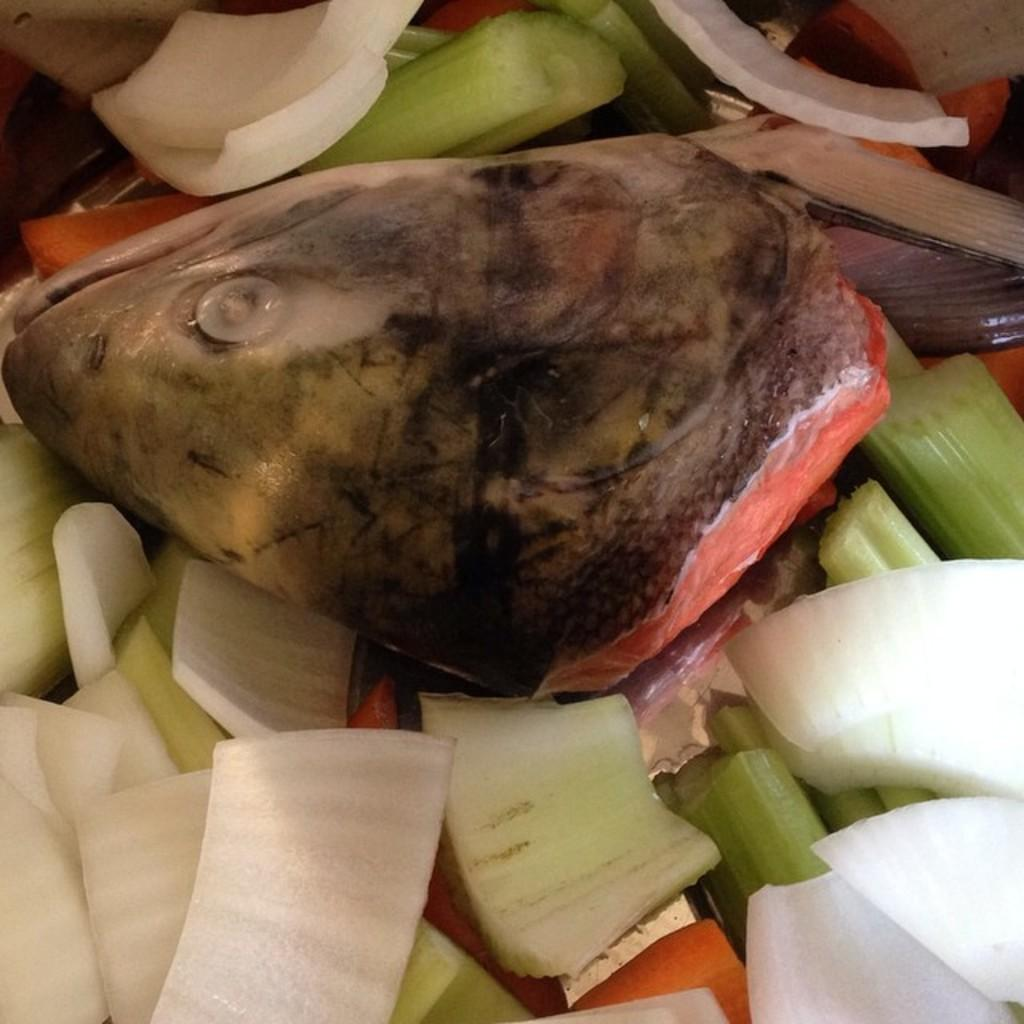What is the main subject of the image? The main subject of the image is the head of a fish. What other items can be seen in the image? There are onion pieces in the image. What type of roof can be seen on the chessboard in the image? There is no chessboard or roof present in the image; it features the head of a fish and onion pieces. 